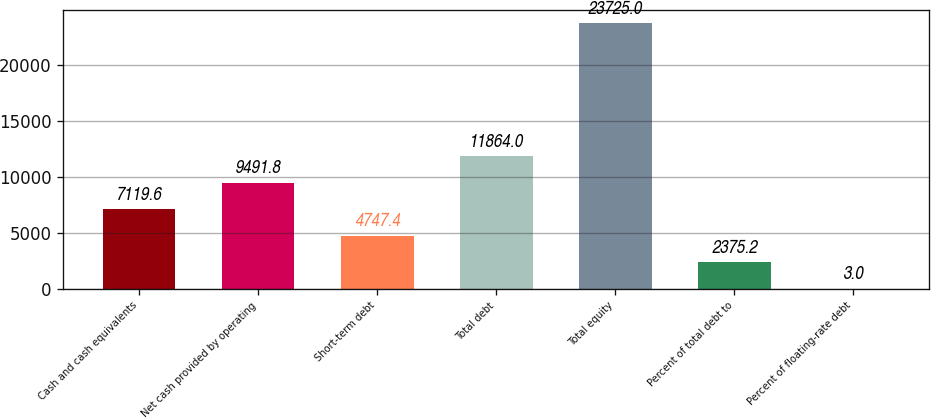Convert chart. <chart><loc_0><loc_0><loc_500><loc_500><bar_chart><fcel>Cash and cash equivalents<fcel>Net cash provided by operating<fcel>Short-term debt<fcel>Total debt<fcel>Total equity<fcel>Percent of total debt to<fcel>Percent of floating-rate debt<nl><fcel>7119.6<fcel>9491.8<fcel>4747.4<fcel>11864<fcel>23725<fcel>2375.2<fcel>3<nl></chart> 